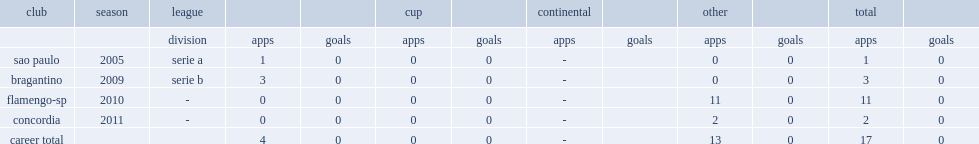Which league did arthur santa rita da lima play the 2009 for bragantino? Serie b. 